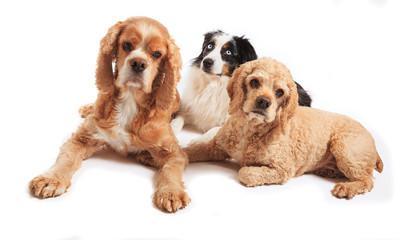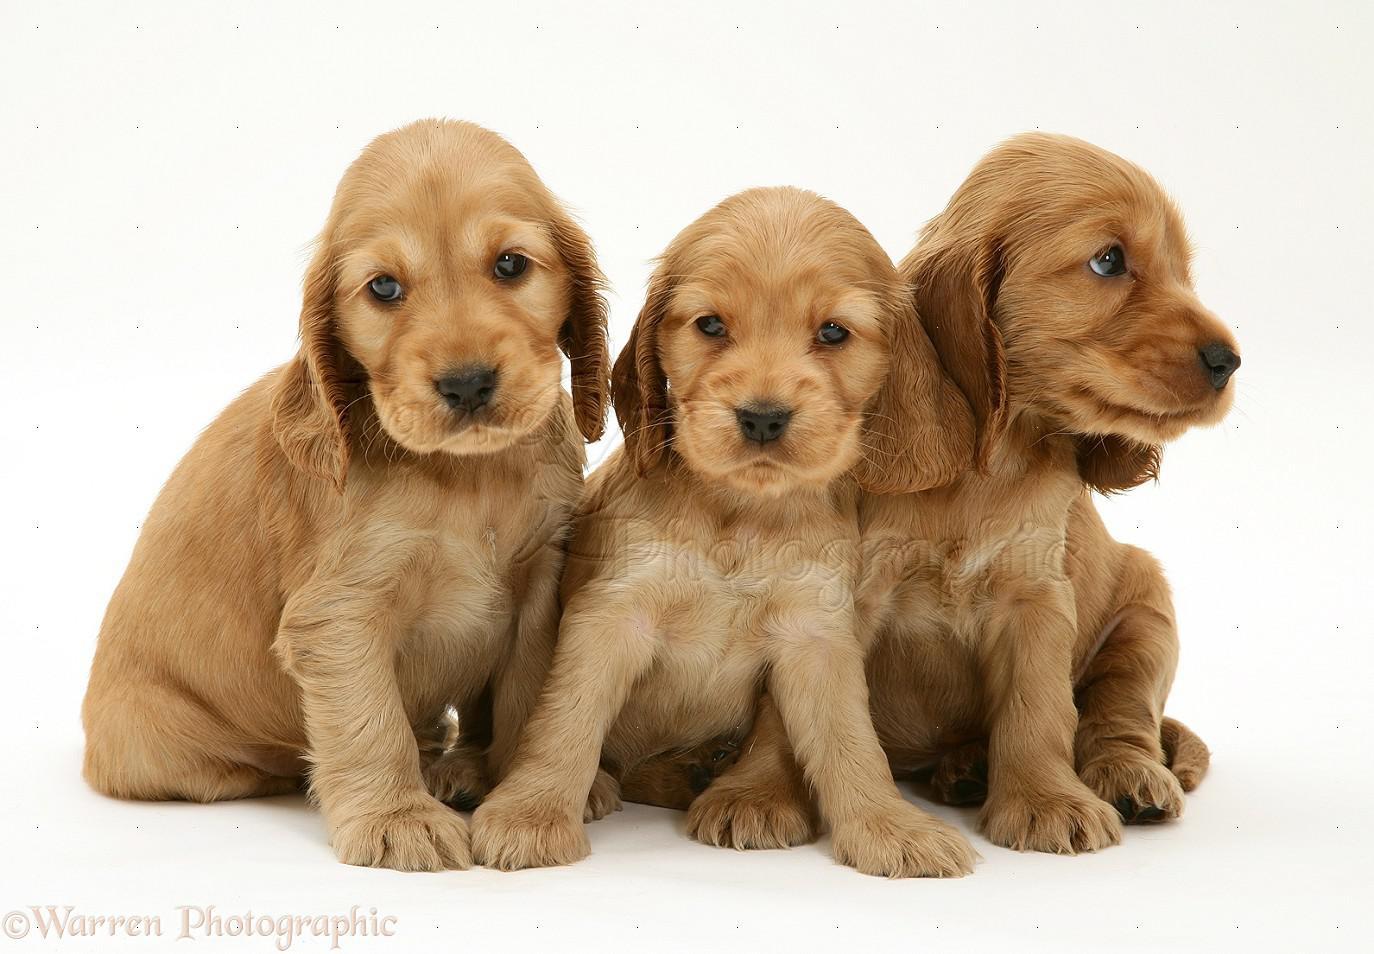The first image is the image on the left, the second image is the image on the right. Analyze the images presented: Is the assertion "Every image shoes exactly three dogs, where in one image all three dogs are blond colored and the other image they have varying colors." valid? Answer yes or no. Yes. The first image is the image on the left, the second image is the image on the right. Analyze the images presented: Is the assertion "There is exactly three dogs in the left image." valid? Answer yes or no. Yes. 